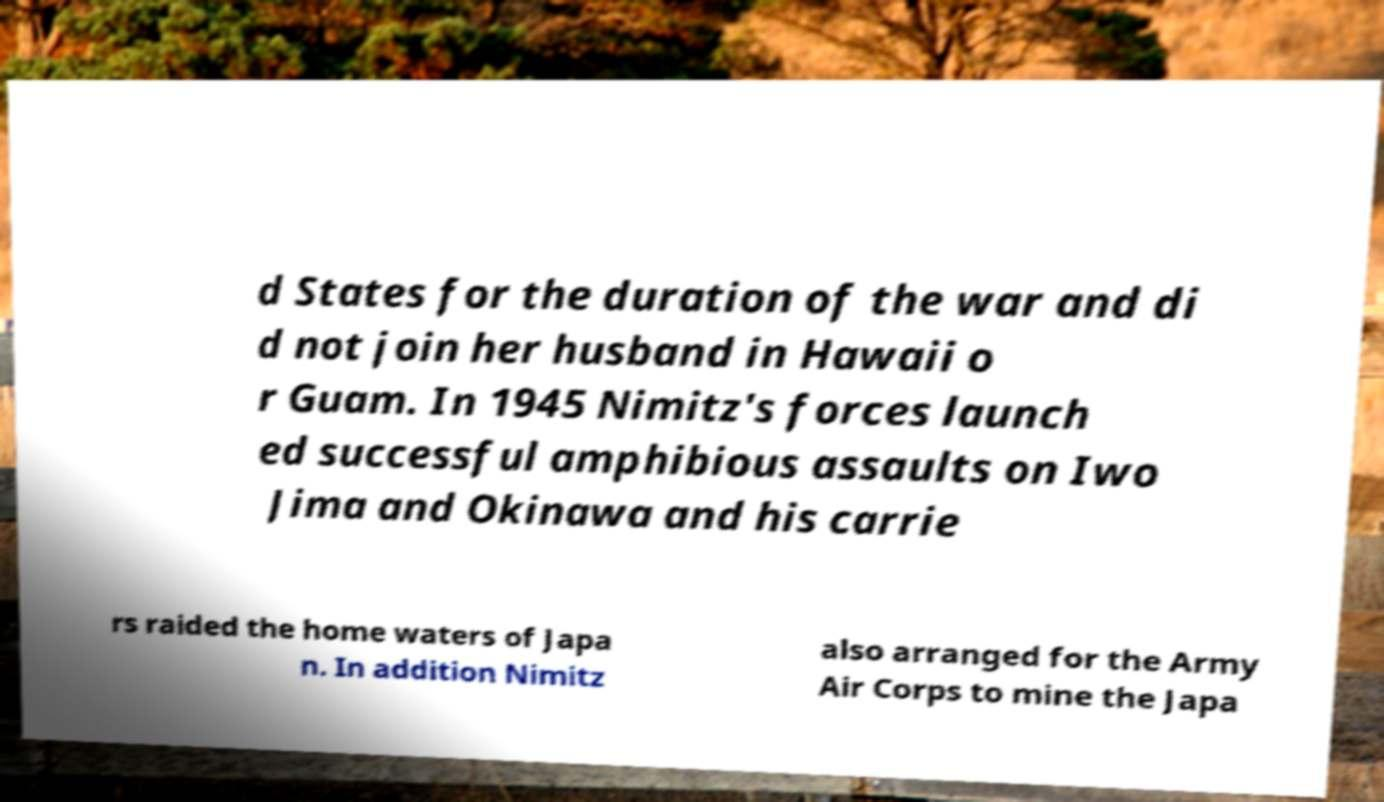Can you read and provide the text displayed in the image?This photo seems to have some interesting text. Can you extract and type it out for me? d States for the duration of the war and di d not join her husband in Hawaii o r Guam. In 1945 Nimitz's forces launch ed successful amphibious assaults on Iwo Jima and Okinawa and his carrie rs raided the home waters of Japa n. In addition Nimitz also arranged for the Army Air Corps to mine the Japa 